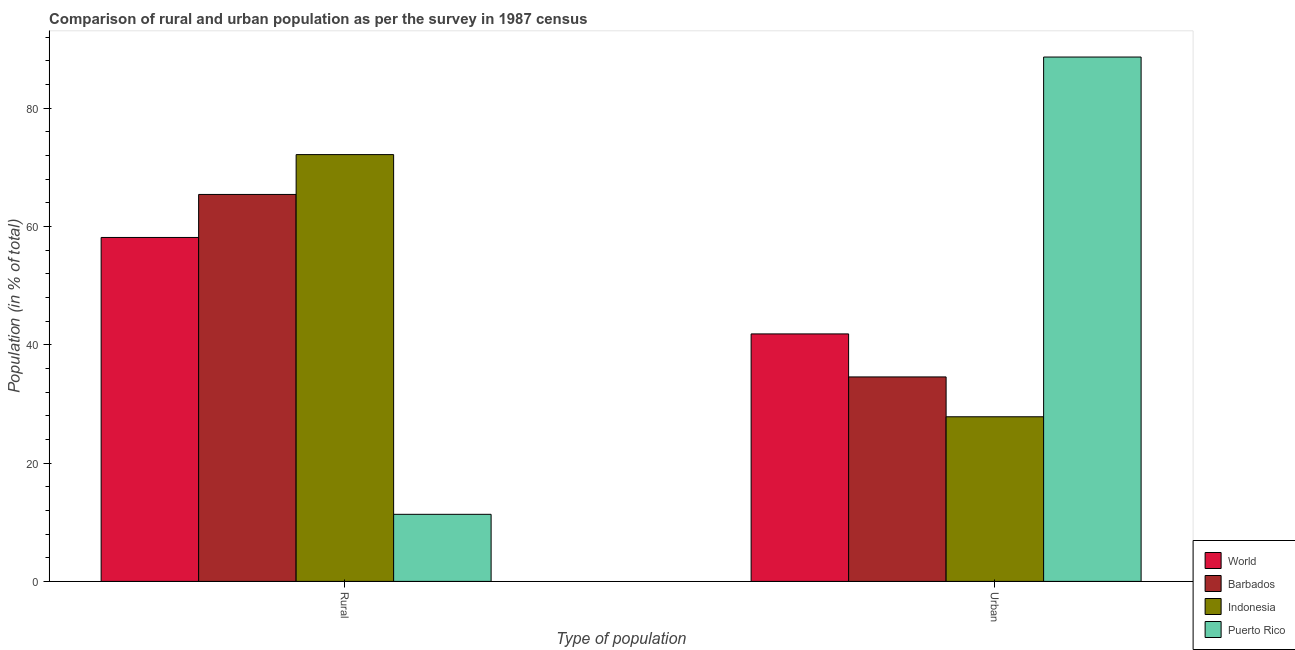How many different coloured bars are there?
Make the answer very short. 4. Are the number of bars on each tick of the X-axis equal?
Offer a very short reply. Yes. How many bars are there on the 1st tick from the left?
Give a very brief answer. 4. What is the label of the 2nd group of bars from the left?
Provide a short and direct response. Urban. What is the rural population in Barbados?
Your answer should be very brief. 65.43. Across all countries, what is the maximum rural population?
Provide a succinct answer. 72.17. Across all countries, what is the minimum rural population?
Ensure brevity in your answer.  11.34. In which country was the rural population maximum?
Make the answer very short. Indonesia. In which country was the urban population minimum?
Offer a very short reply. Indonesia. What is the total rural population in the graph?
Offer a terse response. 207.09. What is the difference between the rural population in Puerto Rico and that in Indonesia?
Keep it short and to the point. -60.83. What is the difference between the rural population in Puerto Rico and the urban population in Barbados?
Your answer should be very brief. -23.23. What is the average rural population per country?
Ensure brevity in your answer.  51.77. What is the difference between the urban population and rural population in World?
Your answer should be compact. -16.31. What is the ratio of the rural population in Indonesia to that in Puerto Rico?
Give a very brief answer. 6.36. In how many countries, is the rural population greater than the average rural population taken over all countries?
Offer a terse response. 3. What does the 4th bar from the left in Urban represents?
Your response must be concise. Puerto Rico. How many bars are there?
Ensure brevity in your answer.  8. Are the values on the major ticks of Y-axis written in scientific E-notation?
Your answer should be very brief. No. Does the graph contain grids?
Provide a succinct answer. No. What is the title of the graph?
Provide a succinct answer. Comparison of rural and urban population as per the survey in 1987 census. Does "Andorra" appear as one of the legend labels in the graph?
Your answer should be very brief. No. What is the label or title of the X-axis?
Your response must be concise. Type of population. What is the label or title of the Y-axis?
Make the answer very short. Population (in % of total). What is the Population (in % of total) in World in Rural?
Provide a short and direct response. 58.16. What is the Population (in % of total) of Barbados in Rural?
Your answer should be compact. 65.43. What is the Population (in % of total) in Indonesia in Rural?
Give a very brief answer. 72.17. What is the Population (in % of total) of Puerto Rico in Rural?
Ensure brevity in your answer.  11.34. What is the Population (in % of total) in World in Urban?
Your answer should be very brief. 41.84. What is the Population (in % of total) in Barbados in Urban?
Provide a short and direct response. 34.57. What is the Population (in % of total) of Indonesia in Urban?
Offer a very short reply. 27.84. What is the Population (in % of total) of Puerto Rico in Urban?
Make the answer very short. 88.66. Across all Type of population, what is the maximum Population (in % of total) of World?
Your answer should be compact. 58.16. Across all Type of population, what is the maximum Population (in % of total) in Barbados?
Your answer should be very brief. 65.43. Across all Type of population, what is the maximum Population (in % of total) of Indonesia?
Make the answer very short. 72.17. Across all Type of population, what is the maximum Population (in % of total) of Puerto Rico?
Provide a short and direct response. 88.66. Across all Type of population, what is the minimum Population (in % of total) of World?
Your response must be concise. 41.84. Across all Type of population, what is the minimum Population (in % of total) of Barbados?
Your response must be concise. 34.57. Across all Type of population, what is the minimum Population (in % of total) in Indonesia?
Ensure brevity in your answer.  27.84. Across all Type of population, what is the minimum Population (in % of total) of Puerto Rico?
Your answer should be compact. 11.34. What is the total Population (in % of total) in World in the graph?
Make the answer very short. 100. What is the total Population (in % of total) in Barbados in the graph?
Offer a very short reply. 100. What is the total Population (in % of total) of Indonesia in the graph?
Provide a short and direct response. 100. What is the total Population (in % of total) in Puerto Rico in the graph?
Your answer should be very brief. 100. What is the difference between the Population (in % of total) in World in Rural and that in Urban?
Your answer should be very brief. 16.31. What is the difference between the Population (in % of total) of Barbados in Rural and that in Urban?
Provide a succinct answer. 30.86. What is the difference between the Population (in % of total) in Indonesia in Rural and that in Urban?
Keep it short and to the point. 44.33. What is the difference between the Population (in % of total) in Puerto Rico in Rural and that in Urban?
Your response must be concise. -77.32. What is the difference between the Population (in % of total) in World in Rural and the Population (in % of total) in Barbados in Urban?
Your answer should be compact. 23.58. What is the difference between the Population (in % of total) of World in Rural and the Population (in % of total) of Indonesia in Urban?
Your answer should be compact. 30.32. What is the difference between the Population (in % of total) in World in Rural and the Population (in % of total) in Puerto Rico in Urban?
Your response must be concise. -30.5. What is the difference between the Population (in % of total) in Barbados in Rural and the Population (in % of total) in Indonesia in Urban?
Your response must be concise. 37.59. What is the difference between the Population (in % of total) of Barbados in Rural and the Population (in % of total) of Puerto Rico in Urban?
Provide a short and direct response. -23.23. What is the difference between the Population (in % of total) in Indonesia in Rural and the Population (in % of total) in Puerto Rico in Urban?
Ensure brevity in your answer.  -16.5. What is the difference between the Population (in % of total) in World and Population (in % of total) in Barbados in Rural?
Offer a very short reply. -7.27. What is the difference between the Population (in % of total) of World and Population (in % of total) of Indonesia in Rural?
Keep it short and to the point. -14.01. What is the difference between the Population (in % of total) of World and Population (in % of total) of Puerto Rico in Rural?
Offer a very short reply. 46.82. What is the difference between the Population (in % of total) of Barbados and Population (in % of total) of Indonesia in Rural?
Ensure brevity in your answer.  -6.74. What is the difference between the Population (in % of total) in Barbados and Population (in % of total) in Puerto Rico in Rural?
Ensure brevity in your answer.  54.09. What is the difference between the Population (in % of total) in Indonesia and Population (in % of total) in Puerto Rico in Rural?
Keep it short and to the point. 60.83. What is the difference between the Population (in % of total) in World and Population (in % of total) in Barbados in Urban?
Offer a very short reply. 7.27. What is the difference between the Population (in % of total) of World and Population (in % of total) of Indonesia in Urban?
Your answer should be compact. 14.01. What is the difference between the Population (in % of total) of World and Population (in % of total) of Puerto Rico in Urban?
Ensure brevity in your answer.  -46.82. What is the difference between the Population (in % of total) of Barbados and Population (in % of total) of Indonesia in Urban?
Your answer should be compact. 6.74. What is the difference between the Population (in % of total) in Barbados and Population (in % of total) in Puerto Rico in Urban?
Offer a very short reply. -54.09. What is the difference between the Population (in % of total) of Indonesia and Population (in % of total) of Puerto Rico in Urban?
Your answer should be compact. -60.83. What is the ratio of the Population (in % of total) of World in Rural to that in Urban?
Your answer should be very brief. 1.39. What is the ratio of the Population (in % of total) of Barbados in Rural to that in Urban?
Ensure brevity in your answer.  1.89. What is the ratio of the Population (in % of total) of Indonesia in Rural to that in Urban?
Make the answer very short. 2.59. What is the ratio of the Population (in % of total) of Puerto Rico in Rural to that in Urban?
Offer a very short reply. 0.13. What is the difference between the highest and the second highest Population (in % of total) in World?
Give a very brief answer. 16.31. What is the difference between the highest and the second highest Population (in % of total) of Barbados?
Your answer should be compact. 30.86. What is the difference between the highest and the second highest Population (in % of total) in Indonesia?
Provide a short and direct response. 44.33. What is the difference between the highest and the second highest Population (in % of total) in Puerto Rico?
Keep it short and to the point. 77.32. What is the difference between the highest and the lowest Population (in % of total) of World?
Ensure brevity in your answer.  16.31. What is the difference between the highest and the lowest Population (in % of total) of Barbados?
Ensure brevity in your answer.  30.86. What is the difference between the highest and the lowest Population (in % of total) in Indonesia?
Offer a terse response. 44.33. What is the difference between the highest and the lowest Population (in % of total) of Puerto Rico?
Keep it short and to the point. 77.32. 